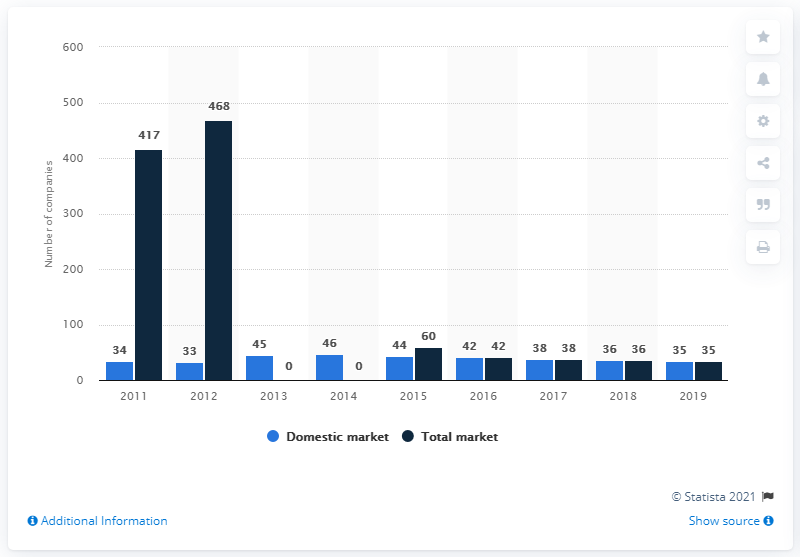Specify some key components in this picture. From 2011 to 2014, there were a total of 46 companies operating in the Bulgarian insurance market. In 2019, there were 35 companies operating in the Bulgarian insurance market. 